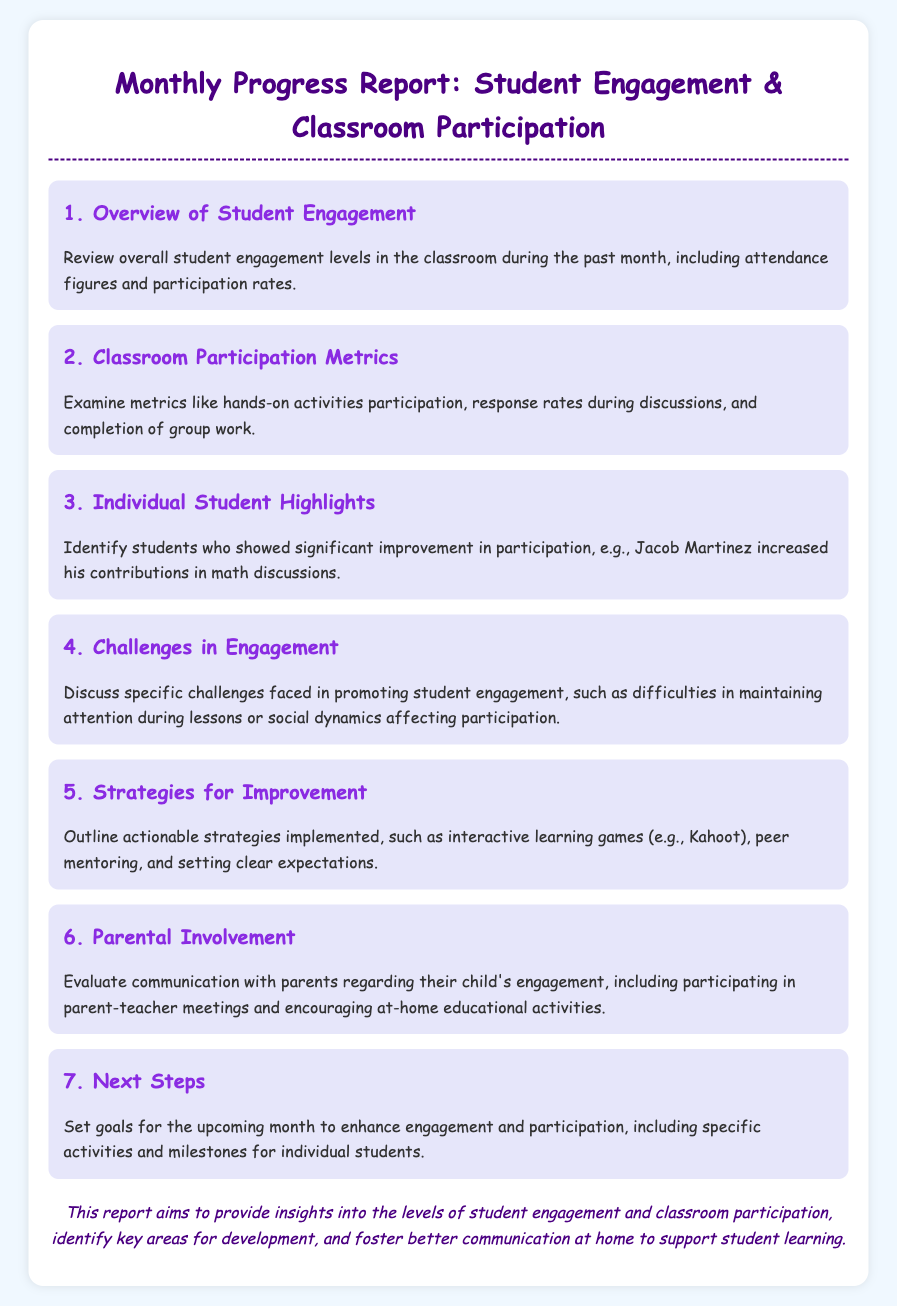What is the title of the report? The title of the report is stated prominently at the top of the document, indicating its purpose and focus.
Answer: Monthly Progress Report: Student Engagement & Classroom Participation How many agenda items are listed in the document? The document includes a clear enumeration of the agenda items throughout the content, allowing for a straightforward count.
Answer: 7 Who is identified as a student showing significant improvement in participation? The document highlights an individual student's progress in an area specifically related to class contributions, making this easily identifiable.
Answer: Jacob Martinez What strategy is mentioned for improving engagement? One of the strategies to enhance engagement is specifically outlined within the document, providing practical examples.
Answer: Interactive learning games (e.g., Kahoot) What section discusses challenges faced in promoting student engagement? A dedicated part of the document addresses the issues encountered, detailing specific challenges experienced in the classroom.
Answer: Challenges in Engagement How does the report suggest involving parents? There is a mention of a specific method regarding parental engagement and its evaluation towards their child’s involvement in class activities.
Answer: Evaluate communication with parents What is the main aim of this report? The report's purpose is summarized in the conclusion, capturing the overall intention behind its creation.
Answer: Provide insights into the levels of student engagement and classroom participation 